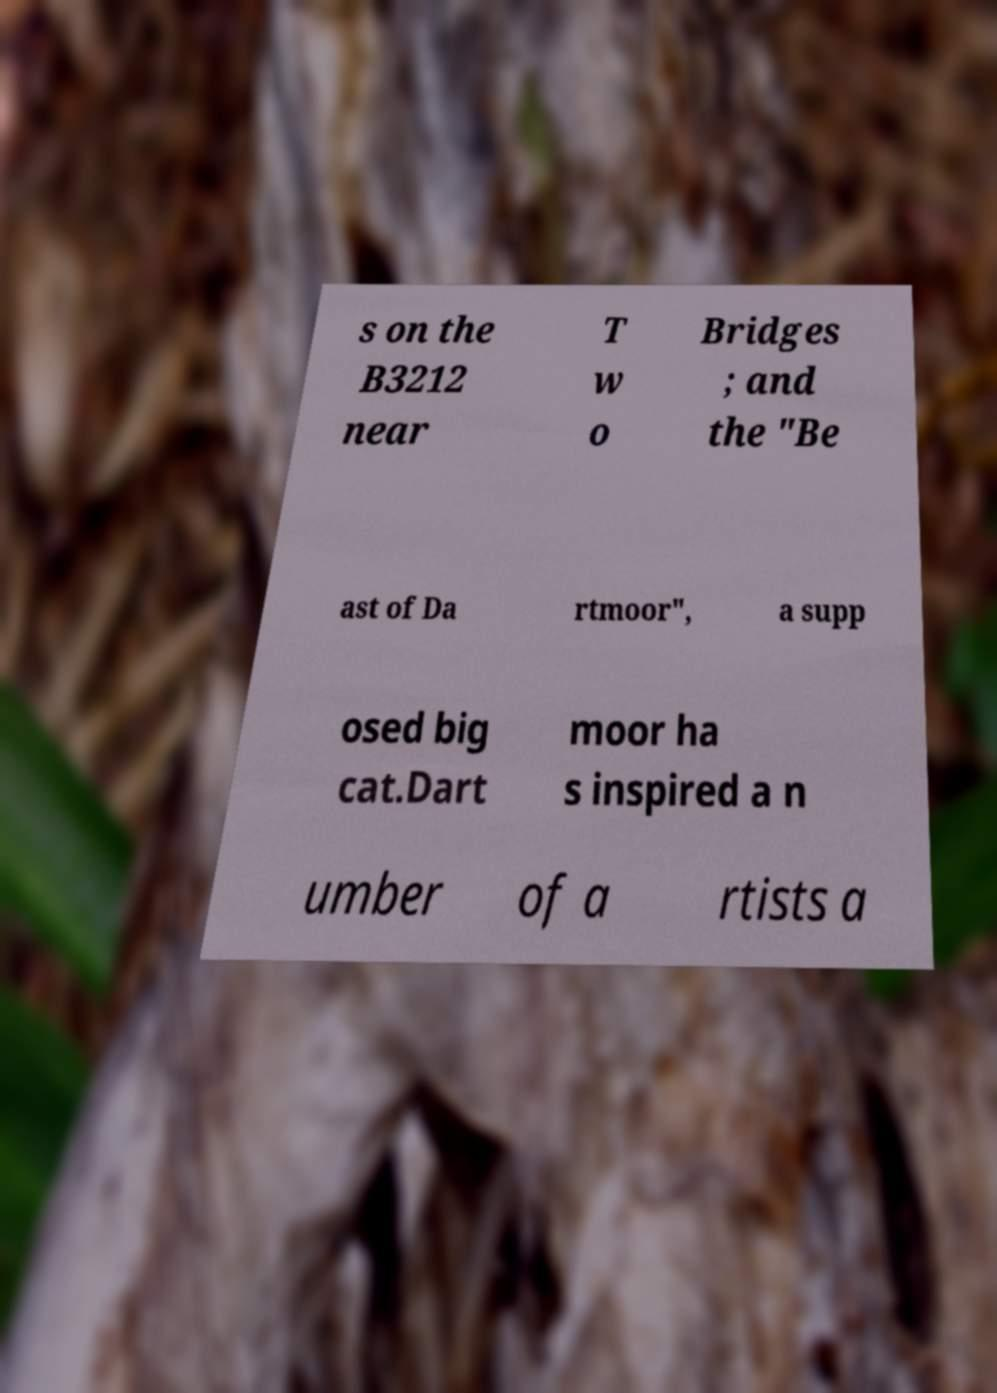Could you extract and type out the text from this image? s on the B3212 near T w o Bridges ; and the "Be ast of Da rtmoor", a supp osed big cat.Dart moor ha s inspired a n umber of a rtists a 